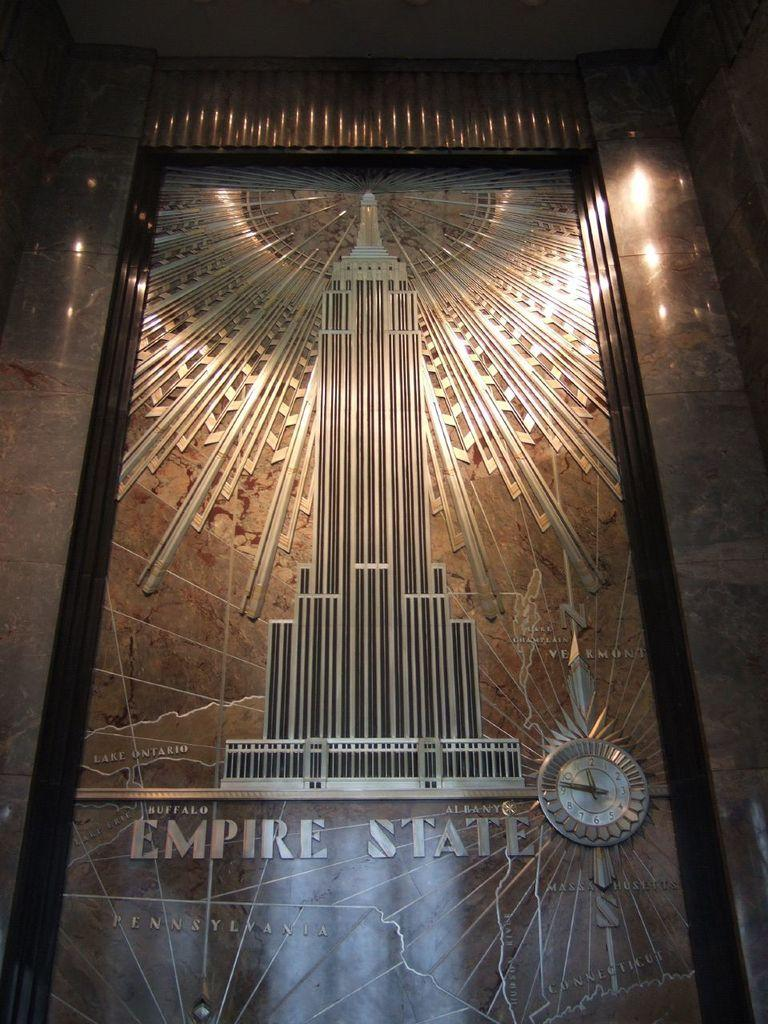Provide a one-sentence caption for the provided image. A piece of artwork that features the Empire State Building is made out of metal. 